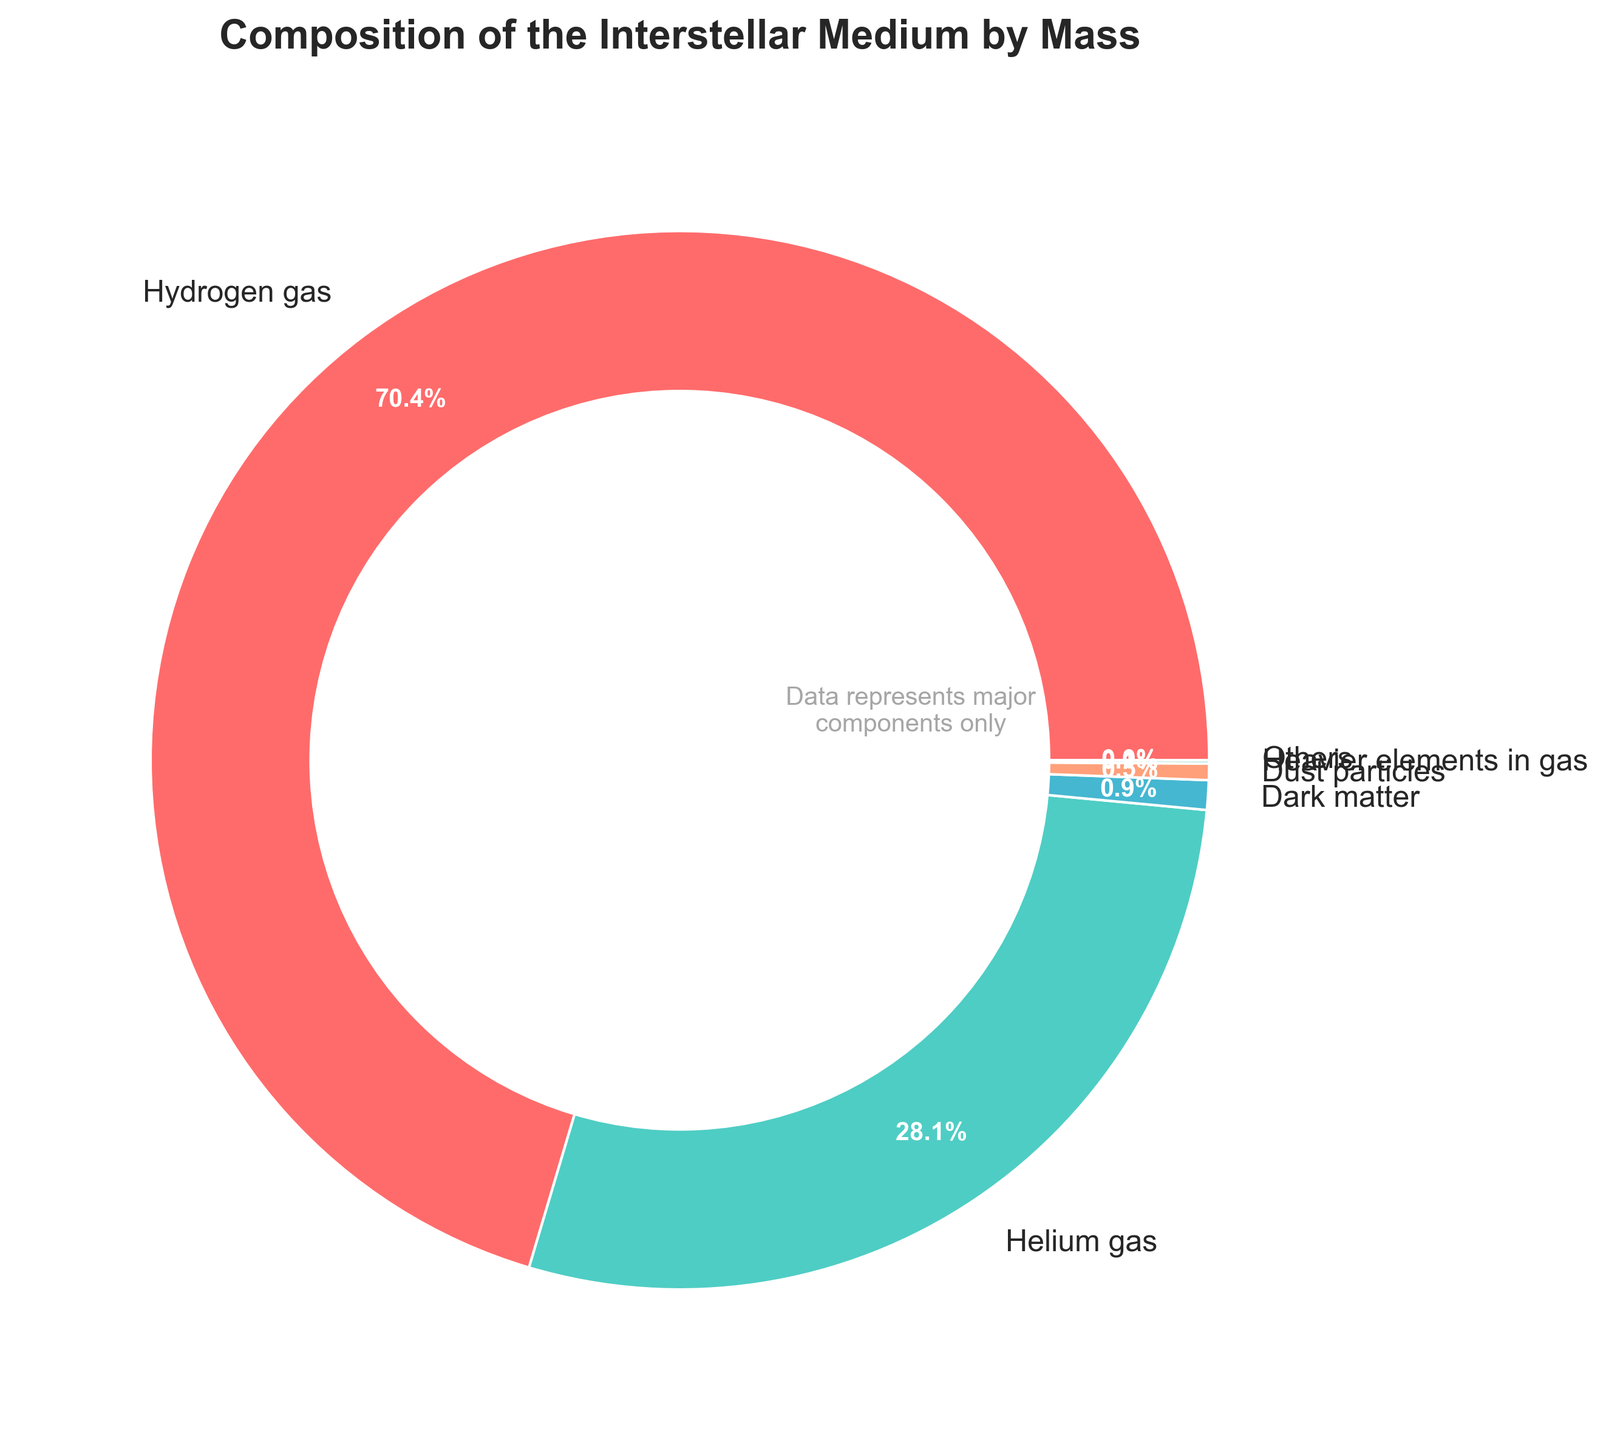What is the percentage of Hydrogen gas in the interstellar medium? Hydrogen gas is one of the components listed in the figure. According to the values, the percentage of Hydrogen gas is 70.4
Answer: 70.4 Which component has the second-largest percentage in the interstellar medium? By looking at the percentages, the component with the second-largest percentage is Helium gas with 28.1
Answer: Helium gas How does the percentage of Dust particles compare to the percentage of Dark matter? The percentage of Dust particles is 0.5, while the percentage of Dark matter is 0.9. Therefore, Dust particles have a lower percentage compared to Dark matter
Answer: Dust particles have a lower percentage What is the combined percentage of heavier elements and cosmic rays in the interstellar medium? The percentage of heavier elements in gas is 0.1 and the percentage of cosmic rays is 0.01. Adding these together, 0.1 + 0.01 = 0.11
Answer: 0.11 If we sum up all components other than Hydrogen gas and Helium gas, what is their total percentage? To find this, we subtract the percentages of Hydrogen gas and Helium gas from 100. That is, 100 - (70.4 + 28.1) = 100 - 98.5 = 1.5
Answer: 1.5 What color represents Dust particles in the chart? Dust particles are represented by one of the wedges. Based on the custom color palette, Dust particles are shown in the color associated with the 4th largest component. The color on the wedge depicting Dust particles is light red or salmon
Answer: light red/salmon Which component is represented by the smallest wedge in the pie chart? As the data is sorted by the top 5 components plus Others, the smallest wedge from those shown corresponds to the component with the lowest percentage among these. Based on the data, this is Dust particles (0.5%)
Answer: Dust particles What is the difference in percentage between the components in the "Others" category and Helium gas? The "Others" category aggregates the remaining components. Its percentage is calculated by subtracting the sum of the top 5 components from 100. Thus, Others = 100 - (70.4 + 28.1 + 0.5 + 0.1 + 0.9) = 100 - 100.0 = 0.0. The difference with Helium gas (28.1%) is 28.1 - 0.0 = 28.1
Answer: 28.1 In the context of the pie chart, what is the median of the represented components' percentages? The median is the middle value when the components' percentages are arranged in ascending order. The top 5 components' percentages are [0.1, 0.5, 0.9, 28.1, 70.4]. The median value of this list is 0.9
Answer: 0.9 